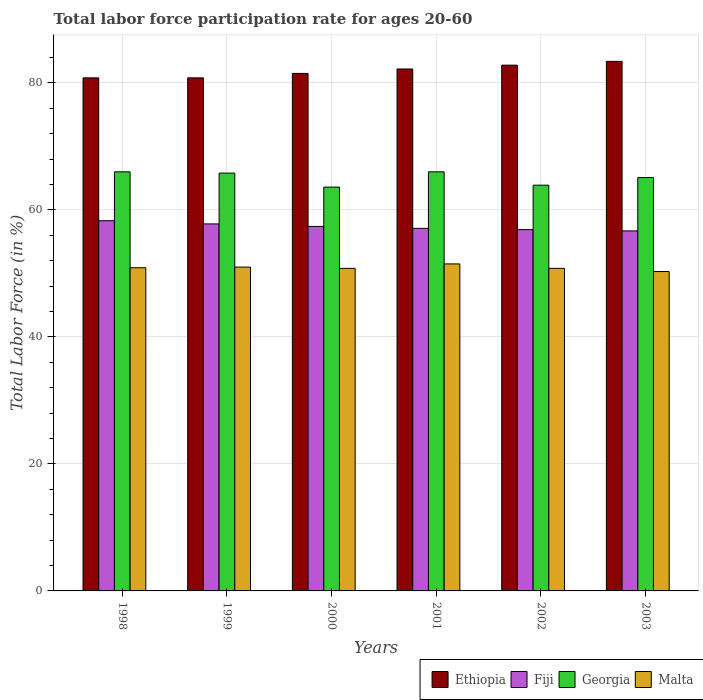How many different coloured bars are there?
Your answer should be compact. 4. Are the number of bars per tick equal to the number of legend labels?
Provide a short and direct response. Yes. Are the number of bars on each tick of the X-axis equal?
Ensure brevity in your answer.  Yes. How many bars are there on the 3rd tick from the right?
Your answer should be very brief. 4. What is the labor force participation rate in Malta in 1998?
Your response must be concise. 50.9. Across all years, what is the maximum labor force participation rate in Malta?
Your response must be concise. 51.5. Across all years, what is the minimum labor force participation rate in Fiji?
Make the answer very short. 56.7. In which year was the labor force participation rate in Fiji maximum?
Provide a short and direct response. 1998. What is the total labor force participation rate in Malta in the graph?
Make the answer very short. 305.3. What is the difference between the labor force participation rate in Malta in 1998 and that in 1999?
Provide a succinct answer. -0.1. What is the difference between the labor force participation rate in Fiji in 2003 and the labor force participation rate in Malta in 1998?
Provide a short and direct response. 5.8. What is the average labor force participation rate in Ethiopia per year?
Offer a terse response. 81.92. In the year 2000, what is the difference between the labor force participation rate in Ethiopia and labor force participation rate in Fiji?
Offer a very short reply. 24.1. In how many years, is the labor force participation rate in Ethiopia greater than 12 %?
Provide a succinct answer. 6. What is the ratio of the labor force participation rate in Ethiopia in 2002 to that in 2003?
Keep it short and to the point. 0.99. Is the difference between the labor force participation rate in Ethiopia in 2000 and 2003 greater than the difference between the labor force participation rate in Fiji in 2000 and 2003?
Keep it short and to the point. No. What is the difference between the highest and the second highest labor force participation rate in Ethiopia?
Your answer should be compact. 0.6. What is the difference between the highest and the lowest labor force participation rate in Ethiopia?
Provide a short and direct response. 2.6. Is it the case that in every year, the sum of the labor force participation rate in Ethiopia and labor force participation rate in Georgia is greater than the sum of labor force participation rate in Malta and labor force participation rate in Fiji?
Provide a short and direct response. Yes. What does the 2nd bar from the left in 1998 represents?
Your answer should be very brief. Fiji. What does the 3rd bar from the right in 2001 represents?
Offer a terse response. Fiji. Is it the case that in every year, the sum of the labor force participation rate in Georgia and labor force participation rate in Ethiopia is greater than the labor force participation rate in Malta?
Your answer should be compact. Yes. Are the values on the major ticks of Y-axis written in scientific E-notation?
Your answer should be very brief. No. Does the graph contain any zero values?
Offer a terse response. No. Does the graph contain grids?
Offer a terse response. Yes. Where does the legend appear in the graph?
Your response must be concise. Bottom right. How are the legend labels stacked?
Provide a succinct answer. Horizontal. What is the title of the graph?
Offer a very short reply. Total labor force participation rate for ages 20-60. What is the label or title of the X-axis?
Make the answer very short. Years. What is the Total Labor Force (in %) in Ethiopia in 1998?
Provide a short and direct response. 80.8. What is the Total Labor Force (in %) in Fiji in 1998?
Ensure brevity in your answer.  58.3. What is the Total Labor Force (in %) of Malta in 1998?
Ensure brevity in your answer.  50.9. What is the Total Labor Force (in %) in Ethiopia in 1999?
Your response must be concise. 80.8. What is the Total Labor Force (in %) of Fiji in 1999?
Provide a short and direct response. 57.8. What is the Total Labor Force (in %) in Georgia in 1999?
Give a very brief answer. 65.8. What is the Total Labor Force (in %) of Ethiopia in 2000?
Provide a short and direct response. 81.5. What is the Total Labor Force (in %) in Fiji in 2000?
Make the answer very short. 57.4. What is the Total Labor Force (in %) of Georgia in 2000?
Keep it short and to the point. 63.6. What is the Total Labor Force (in %) in Malta in 2000?
Keep it short and to the point. 50.8. What is the Total Labor Force (in %) of Ethiopia in 2001?
Offer a terse response. 82.2. What is the Total Labor Force (in %) of Fiji in 2001?
Offer a terse response. 57.1. What is the Total Labor Force (in %) of Malta in 2001?
Provide a succinct answer. 51.5. What is the Total Labor Force (in %) in Ethiopia in 2002?
Keep it short and to the point. 82.8. What is the Total Labor Force (in %) of Fiji in 2002?
Your answer should be compact. 56.9. What is the Total Labor Force (in %) of Georgia in 2002?
Provide a succinct answer. 63.9. What is the Total Labor Force (in %) of Malta in 2002?
Make the answer very short. 50.8. What is the Total Labor Force (in %) in Ethiopia in 2003?
Make the answer very short. 83.4. What is the Total Labor Force (in %) in Fiji in 2003?
Provide a short and direct response. 56.7. What is the Total Labor Force (in %) of Georgia in 2003?
Your answer should be very brief. 65.1. What is the Total Labor Force (in %) of Malta in 2003?
Make the answer very short. 50.3. Across all years, what is the maximum Total Labor Force (in %) of Ethiopia?
Make the answer very short. 83.4. Across all years, what is the maximum Total Labor Force (in %) of Fiji?
Ensure brevity in your answer.  58.3. Across all years, what is the maximum Total Labor Force (in %) of Georgia?
Keep it short and to the point. 66. Across all years, what is the maximum Total Labor Force (in %) in Malta?
Offer a terse response. 51.5. Across all years, what is the minimum Total Labor Force (in %) of Ethiopia?
Your response must be concise. 80.8. Across all years, what is the minimum Total Labor Force (in %) of Fiji?
Offer a terse response. 56.7. Across all years, what is the minimum Total Labor Force (in %) of Georgia?
Keep it short and to the point. 63.6. Across all years, what is the minimum Total Labor Force (in %) of Malta?
Your response must be concise. 50.3. What is the total Total Labor Force (in %) of Ethiopia in the graph?
Your response must be concise. 491.5. What is the total Total Labor Force (in %) of Fiji in the graph?
Make the answer very short. 344.2. What is the total Total Labor Force (in %) in Georgia in the graph?
Your answer should be compact. 390.4. What is the total Total Labor Force (in %) of Malta in the graph?
Provide a succinct answer. 305.3. What is the difference between the Total Labor Force (in %) in Georgia in 1998 and that in 1999?
Provide a succinct answer. 0.2. What is the difference between the Total Labor Force (in %) of Ethiopia in 1998 and that in 2000?
Your answer should be very brief. -0.7. What is the difference between the Total Labor Force (in %) in Fiji in 1998 and that in 2000?
Provide a succinct answer. 0.9. What is the difference between the Total Labor Force (in %) in Georgia in 1998 and that in 2000?
Provide a short and direct response. 2.4. What is the difference between the Total Labor Force (in %) of Malta in 1998 and that in 2000?
Your response must be concise. 0.1. What is the difference between the Total Labor Force (in %) in Ethiopia in 1998 and that in 2001?
Offer a very short reply. -1.4. What is the difference between the Total Labor Force (in %) of Georgia in 1998 and that in 2001?
Give a very brief answer. 0. What is the difference between the Total Labor Force (in %) of Ethiopia in 1998 and that in 2002?
Your answer should be compact. -2. What is the difference between the Total Labor Force (in %) of Fiji in 1998 and that in 2002?
Make the answer very short. 1.4. What is the difference between the Total Labor Force (in %) of Ethiopia in 1998 and that in 2003?
Provide a short and direct response. -2.6. What is the difference between the Total Labor Force (in %) of Georgia in 1998 and that in 2003?
Your answer should be compact. 0.9. What is the difference between the Total Labor Force (in %) in Malta in 1998 and that in 2003?
Make the answer very short. 0.6. What is the difference between the Total Labor Force (in %) in Fiji in 1999 and that in 2000?
Ensure brevity in your answer.  0.4. What is the difference between the Total Labor Force (in %) in Malta in 1999 and that in 2000?
Keep it short and to the point. 0.2. What is the difference between the Total Labor Force (in %) of Fiji in 1999 and that in 2001?
Make the answer very short. 0.7. What is the difference between the Total Labor Force (in %) of Georgia in 1999 and that in 2001?
Make the answer very short. -0.2. What is the difference between the Total Labor Force (in %) in Malta in 1999 and that in 2001?
Your response must be concise. -0.5. What is the difference between the Total Labor Force (in %) in Georgia in 1999 and that in 2002?
Provide a succinct answer. 1.9. What is the difference between the Total Labor Force (in %) in Fiji in 1999 and that in 2003?
Ensure brevity in your answer.  1.1. What is the difference between the Total Labor Force (in %) of Georgia in 2000 and that in 2001?
Your response must be concise. -2.4. What is the difference between the Total Labor Force (in %) in Ethiopia in 2000 and that in 2002?
Provide a short and direct response. -1.3. What is the difference between the Total Labor Force (in %) of Ethiopia in 2000 and that in 2003?
Ensure brevity in your answer.  -1.9. What is the difference between the Total Labor Force (in %) in Fiji in 2001 and that in 2002?
Provide a short and direct response. 0.2. What is the difference between the Total Labor Force (in %) in Georgia in 2001 and that in 2002?
Offer a very short reply. 2.1. What is the difference between the Total Labor Force (in %) in Fiji in 2001 and that in 2003?
Offer a very short reply. 0.4. What is the difference between the Total Labor Force (in %) in Georgia in 2001 and that in 2003?
Ensure brevity in your answer.  0.9. What is the difference between the Total Labor Force (in %) in Malta in 2001 and that in 2003?
Your response must be concise. 1.2. What is the difference between the Total Labor Force (in %) in Ethiopia in 2002 and that in 2003?
Provide a short and direct response. -0.6. What is the difference between the Total Labor Force (in %) in Georgia in 2002 and that in 2003?
Offer a very short reply. -1.2. What is the difference between the Total Labor Force (in %) in Malta in 2002 and that in 2003?
Provide a short and direct response. 0.5. What is the difference between the Total Labor Force (in %) of Ethiopia in 1998 and the Total Labor Force (in %) of Fiji in 1999?
Provide a short and direct response. 23. What is the difference between the Total Labor Force (in %) of Ethiopia in 1998 and the Total Labor Force (in %) of Georgia in 1999?
Offer a terse response. 15. What is the difference between the Total Labor Force (in %) of Ethiopia in 1998 and the Total Labor Force (in %) of Malta in 1999?
Give a very brief answer. 29.8. What is the difference between the Total Labor Force (in %) of Fiji in 1998 and the Total Labor Force (in %) of Malta in 1999?
Keep it short and to the point. 7.3. What is the difference between the Total Labor Force (in %) in Georgia in 1998 and the Total Labor Force (in %) in Malta in 1999?
Ensure brevity in your answer.  15. What is the difference between the Total Labor Force (in %) of Ethiopia in 1998 and the Total Labor Force (in %) of Fiji in 2000?
Provide a short and direct response. 23.4. What is the difference between the Total Labor Force (in %) in Fiji in 1998 and the Total Labor Force (in %) in Georgia in 2000?
Your answer should be very brief. -5.3. What is the difference between the Total Labor Force (in %) of Fiji in 1998 and the Total Labor Force (in %) of Malta in 2000?
Ensure brevity in your answer.  7.5. What is the difference between the Total Labor Force (in %) of Ethiopia in 1998 and the Total Labor Force (in %) of Fiji in 2001?
Offer a very short reply. 23.7. What is the difference between the Total Labor Force (in %) of Ethiopia in 1998 and the Total Labor Force (in %) of Malta in 2001?
Provide a short and direct response. 29.3. What is the difference between the Total Labor Force (in %) in Fiji in 1998 and the Total Labor Force (in %) in Georgia in 2001?
Ensure brevity in your answer.  -7.7. What is the difference between the Total Labor Force (in %) of Ethiopia in 1998 and the Total Labor Force (in %) of Fiji in 2002?
Provide a succinct answer. 23.9. What is the difference between the Total Labor Force (in %) in Ethiopia in 1998 and the Total Labor Force (in %) in Malta in 2002?
Give a very brief answer. 30. What is the difference between the Total Labor Force (in %) in Fiji in 1998 and the Total Labor Force (in %) in Malta in 2002?
Give a very brief answer. 7.5. What is the difference between the Total Labor Force (in %) of Georgia in 1998 and the Total Labor Force (in %) of Malta in 2002?
Keep it short and to the point. 15.2. What is the difference between the Total Labor Force (in %) of Ethiopia in 1998 and the Total Labor Force (in %) of Fiji in 2003?
Ensure brevity in your answer.  24.1. What is the difference between the Total Labor Force (in %) of Ethiopia in 1998 and the Total Labor Force (in %) of Malta in 2003?
Provide a succinct answer. 30.5. What is the difference between the Total Labor Force (in %) in Fiji in 1998 and the Total Labor Force (in %) in Georgia in 2003?
Your answer should be compact. -6.8. What is the difference between the Total Labor Force (in %) of Fiji in 1998 and the Total Labor Force (in %) of Malta in 2003?
Ensure brevity in your answer.  8. What is the difference between the Total Labor Force (in %) in Ethiopia in 1999 and the Total Labor Force (in %) in Fiji in 2000?
Keep it short and to the point. 23.4. What is the difference between the Total Labor Force (in %) in Ethiopia in 1999 and the Total Labor Force (in %) in Malta in 2000?
Give a very brief answer. 30. What is the difference between the Total Labor Force (in %) in Ethiopia in 1999 and the Total Labor Force (in %) in Fiji in 2001?
Offer a terse response. 23.7. What is the difference between the Total Labor Force (in %) of Ethiopia in 1999 and the Total Labor Force (in %) of Malta in 2001?
Provide a short and direct response. 29.3. What is the difference between the Total Labor Force (in %) in Georgia in 1999 and the Total Labor Force (in %) in Malta in 2001?
Offer a very short reply. 14.3. What is the difference between the Total Labor Force (in %) in Ethiopia in 1999 and the Total Labor Force (in %) in Fiji in 2002?
Give a very brief answer. 23.9. What is the difference between the Total Labor Force (in %) of Ethiopia in 1999 and the Total Labor Force (in %) of Malta in 2002?
Your response must be concise. 30. What is the difference between the Total Labor Force (in %) in Fiji in 1999 and the Total Labor Force (in %) in Georgia in 2002?
Offer a very short reply. -6.1. What is the difference between the Total Labor Force (in %) in Fiji in 1999 and the Total Labor Force (in %) in Malta in 2002?
Your answer should be compact. 7. What is the difference between the Total Labor Force (in %) of Ethiopia in 1999 and the Total Labor Force (in %) of Fiji in 2003?
Your answer should be compact. 24.1. What is the difference between the Total Labor Force (in %) in Ethiopia in 1999 and the Total Labor Force (in %) in Georgia in 2003?
Give a very brief answer. 15.7. What is the difference between the Total Labor Force (in %) in Ethiopia in 1999 and the Total Labor Force (in %) in Malta in 2003?
Offer a terse response. 30.5. What is the difference between the Total Labor Force (in %) in Georgia in 1999 and the Total Labor Force (in %) in Malta in 2003?
Give a very brief answer. 15.5. What is the difference between the Total Labor Force (in %) of Ethiopia in 2000 and the Total Labor Force (in %) of Fiji in 2001?
Keep it short and to the point. 24.4. What is the difference between the Total Labor Force (in %) in Ethiopia in 2000 and the Total Labor Force (in %) in Georgia in 2001?
Your answer should be very brief. 15.5. What is the difference between the Total Labor Force (in %) of Ethiopia in 2000 and the Total Labor Force (in %) of Malta in 2001?
Give a very brief answer. 30. What is the difference between the Total Labor Force (in %) of Fiji in 2000 and the Total Labor Force (in %) of Georgia in 2001?
Provide a short and direct response. -8.6. What is the difference between the Total Labor Force (in %) of Fiji in 2000 and the Total Labor Force (in %) of Malta in 2001?
Your answer should be very brief. 5.9. What is the difference between the Total Labor Force (in %) of Ethiopia in 2000 and the Total Labor Force (in %) of Fiji in 2002?
Your response must be concise. 24.6. What is the difference between the Total Labor Force (in %) in Ethiopia in 2000 and the Total Labor Force (in %) in Georgia in 2002?
Your answer should be very brief. 17.6. What is the difference between the Total Labor Force (in %) of Ethiopia in 2000 and the Total Labor Force (in %) of Malta in 2002?
Your answer should be very brief. 30.7. What is the difference between the Total Labor Force (in %) in Ethiopia in 2000 and the Total Labor Force (in %) in Fiji in 2003?
Your answer should be very brief. 24.8. What is the difference between the Total Labor Force (in %) in Ethiopia in 2000 and the Total Labor Force (in %) in Georgia in 2003?
Keep it short and to the point. 16.4. What is the difference between the Total Labor Force (in %) of Ethiopia in 2000 and the Total Labor Force (in %) of Malta in 2003?
Ensure brevity in your answer.  31.2. What is the difference between the Total Labor Force (in %) in Georgia in 2000 and the Total Labor Force (in %) in Malta in 2003?
Make the answer very short. 13.3. What is the difference between the Total Labor Force (in %) in Ethiopia in 2001 and the Total Labor Force (in %) in Fiji in 2002?
Give a very brief answer. 25.3. What is the difference between the Total Labor Force (in %) of Ethiopia in 2001 and the Total Labor Force (in %) of Georgia in 2002?
Provide a short and direct response. 18.3. What is the difference between the Total Labor Force (in %) in Ethiopia in 2001 and the Total Labor Force (in %) in Malta in 2002?
Your response must be concise. 31.4. What is the difference between the Total Labor Force (in %) in Fiji in 2001 and the Total Labor Force (in %) in Georgia in 2002?
Ensure brevity in your answer.  -6.8. What is the difference between the Total Labor Force (in %) in Georgia in 2001 and the Total Labor Force (in %) in Malta in 2002?
Provide a short and direct response. 15.2. What is the difference between the Total Labor Force (in %) of Ethiopia in 2001 and the Total Labor Force (in %) of Fiji in 2003?
Give a very brief answer. 25.5. What is the difference between the Total Labor Force (in %) in Ethiopia in 2001 and the Total Labor Force (in %) in Georgia in 2003?
Offer a terse response. 17.1. What is the difference between the Total Labor Force (in %) of Ethiopia in 2001 and the Total Labor Force (in %) of Malta in 2003?
Offer a very short reply. 31.9. What is the difference between the Total Labor Force (in %) of Fiji in 2001 and the Total Labor Force (in %) of Malta in 2003?
Make the answer very short. 6.8. What is the difference between the Total Labor Force (in %) in Georgia in 2001 and the Total Labor Force (in %) in Malta in 2003?
Offer a terse response. 15.7. What is the difference between the Total Labor Force (in %) in Ethiopia in 2002 and the Total Labor Force (in %) in Fiji in 2003?
Make the answer very short. 26.1. What is the difference between the Total Labor Force (in %) in Ethiopia in 2002 and the Total Labor Force (in %) in Malta in 2003?
Provide a succinct answer. 32.5. What is the average Total Labor Force (in %) of Ethiopia per year?
Provide a succinct answer. 81.92. What is the average Total Labor Force (in %) in Fiji per year?
Give a very brief answer. 57.37. What is the average Total Labor Force (in %) of Georgia per year?
Your response must be concise. 65.07. What is the average Total Labor Force (in %) of Malta per year?
Provide a short and direct response. 50.88. In the year 1998, what is the difference between the Total Labor Force (in %) of Ethiopia and Total Labor Force (in %) of Malta?
Your response must be concise. 29.9. In the year 1998, what is the difference between the Total Labor Force (in %) of Georgia and Total Labor Force (in %) of Malta?
Ensure brevity in your answer.  15.1. In the year 1999, what is the difference between the Total Labor Force (in %) of Ethiopia and Total Labor Force (in %) of Fiji?
Ensure brevity in your answer.  23. In the year 1999, what is the difference between the Total Labor Force (in %) in Ethiopia and Total Labor Force (in %) in Malta?
Make the answer very short. 29.8. In the year 1999, what is the difference between the Total Labor Force (in %) of Fiji and Total Labor Force (in %) of Georgia?
Keep it short and to the point. -8. In the year 2000, what is the difference between the Total Labor Force (in %) of Ethiopia and Total Labor Force (in %) of Fiji?
Ensure brevity in your answer.  24.1. In the year 2000, what is the difference between the Total Labor Force (in %) in Ethiopia and Total Labor Force (in %) in Malta?
Offer a very short reply. 30.7. In the year 2000, what is the difference between the Total Labor Force (in %) in Fiji and Total Labor Force (in %) in Malta?
Your answer should be compact. 6.6. In the year 2001, what is the difference between the Total Labor Force (in %) in Ethiopia and Total Labor Force (in %) in Fiji?
Offer a very short reply. 25.1. In the year 2001, what is the difference between the Total Labor Force (in %) in Ethiopia and Total Labor Force (in %) in Malta?
Give a very brief answer. 30.7. In the year 2002, what is the difference between the Total Labor Force (in %) of Ethiopia and Total Labor Force (in %) of Fiji?
Your response must be concise. 25.9. In the year 2002, what is the difference between the Total Labor Force (in %) of Ethiopia and Total Labor Force (in %) of Malta?
Offer a very short reply. 32. In the year 2002, what is the difference between the Total Labor Force (in %) of Fiji and Total Labor Force (in %) of Georgia?
Your response must be concise. -7. In the year 2003, what is the difference between the Total Labor Force (in %) in Ethiopia and Total Labor Force (in %) in Fiji?
Your answer should be very brief. 26.7. In the year 2003, what is the difference between the Total Labor Force (in %) of Ethiopia and Total Labor Force (in %) of Malta?
Provide a short and direct response. 33.1. In the year 2003, what is the difference between the Total Labor Force (in %) in Fiji and Total Labor Force (in %) in Malta?
Your answer should be compact. 6.4. What is the ratio of the Total Labor Force (in %) of Ethiopia in 1998 to that in 1999?
Offer a terse response. 1. What is the ratio of the Total Labor Force (in %) in Fiji in 1998 to that in 1999?
Provide a succinct answer. 1.01. What is the ratio of the Total Labor Force (in %) of Malta in 1998 to that in 1999?
Ensure brevity in your answer.  1. What is the ratio of the Total Labor Force (in %) of Fiji in 1998 to that in 2000?
Your answer should be very brief. 1.02. What is the ratio of the Total Labor Force (in %) of Georgia in 1998 to that in 2000?
Give a very brief answer. 1.04. What is the ratio of the Total Labor Force (in %) of Ethiopia in 1998 to that in 2001?
Offer a terse response. 0.98. What is the ratio of the Total Labor Force (in %) of Fiji in 1998 to that in 2001?
Offer a very short reply. 1.02. What is the ratio of the Total Labor Force (in %) in Malta in 1998 to that in 2001?
Provide a succinct answer. 0.99. What is the ratio of the Total Labor Force (in %) of Ethiopia in 1998 to that in 2002?
Your answer should be very brief. 0.98. What is the ratio of the Total Labor Force (in %) in Fiji in 1998 to that in 2002?
Provide a succinct answer. 1.02. What is the ratio of the Total Labor Force (in %) in Georgia in 1998 to that in 2002?
Your answer should be very brief. 1.03. What is the ratio of the Total Labor Force (in %) of Ethiopia in 1998 to that in 2003?
Ensure brevity in your answer.  0.97. What is the ratio of the Total Labor Force (in %) in Fiji in 1998 to that in 2003?
Provide a succinct answer. 1.03. What is the ratio of the Total Labor Force (in %) in Georgia in 1998 to that in 2003?
Make the answer very short. 1.01. What is the ratio of the Total Labor Force (in %) in Malta in 1998 to that in 2003?
Give a very brief answer. 1.01. What is the ratio of the Total Labor Force (in %) of Fiji in 1999 to that in 2000?
Keep it short and to the point. 1.01. What is the ratio of the Total Labor Force (in %) in Georgia in 1999 to that in 2000?
Give a very brief answer. 1.03. What is the ratio of the Total Labor Force (in %) in Ethiopia in 1999 to that in 2001?
Your answer should be very brief. 0.98. What is the ratio of the Total Labor Force (in %) of Fiji in 1999 to that in 2001?
Your answer should be very brief. 1.01. What is the ratio of the Total Labor Force (in %) in Georgia in 1999 to that in 2001?
Give a very brief answer. 1. What is the ratio of the Total Labor Force (in %) of Malta in 1999 to that in 2001?
Your answer should be compact. 0.99. What is the ratio of the Total Labor Force (in %) in Ethiopia in 1999 to that in 2002?
Offer a terse response. 0.98. What is the ratio of the Total Labor Force (in %) in Fiji in 1999 to that in 2002?
Your answer should be compact. 1.02. What is the ratio of the Total Labor Force (in %) in Georgia in 1999 to that in 2002?
Your answer should be compact. 1.03. What is the ratio of the Total Labor Force (in %) in Ethiopia in 1999 to that in 2003?
Your answer should be compact. 0.97. What is the ratio of the Total Labor Force (in %) of Fiji in 1999 to that in 2003?
Provide a succinct answer. 1.02. What is the ratio of the Total Labor Force (in %) in Georgia in 1999 to that in 2003?
Give a very brief answer. 1.01. What is the ratio of the Total Labor Force (in %) of Malta in 1999 to that in 2003?
Provide a short and direct response. 1.01. What is the ratio of the Total Labor Force (in %) in Fiji in 2000 to that in 2001?
Your response must be concise. 1.01. What is the ratio of the Total Labor Force (in %) in Georgia in 2000 to that in 2001?
Offer a terse response. 0.96. What is the ratio of the Total Labor Force (in %) in Malta in 2000 to that in 2001?
Offer a very short reply. 0.99. What is the ratio of the Total Labor Force (in %) in Ethiopia in 2000 to that in 2002?
Give a very brief answer. 0.98. What is the ratio of the Total Labor Force (in %) of Fiji in 2000 to that in 2002?
Provide a short and direct response. 1.01. What is the ratio of the Total Labor Force (in %) in Ethiopia in 2000 to that in 2003?
Offer a terse response. 0.98. What is the ratio of the Total Labor Force (in %) of Fiji in 2000 to that in 2003?
Your answer should be very brief. 1.01. What is the ratio of the Total Labor Force (in %) of Malta in 2000 to that in 2003?
Your answer should be very brief. 1.01. What is the ratio of the Total Labor Force (in %) of Georgia in 2001 to that in 2002?
Ensure brevity in your answer.  1.03. What is the ratio of the Total Labor Force (in %) of Malta in 2001 to that in 2002?
Keep it short and to the point. 1.01. What is the ratio of the Total Labor Force (in %) in Ethiopia in 2001 to that in 2003?
Give a very brief answer. 0.99. What is the ratio of the Total Labor Force (in %) in Fiji in 2001 to that in 2003?
Keep it short and to the point. 1.01. What is the ratio of the Total Labor Force (in %) in Georgia in 2001 to that in 2003?
Make the answer very short. 1.01. What is the ratio of the Total Labor Force (in %) of Malta in 2001 to that in 2003?
Your response must be concise. 1.02. What is the ratio of the Total Labor Force (in %) in Georgia in 2002 to that in 2003?
Keep it short and to the point. 0.98. What is the ratio of the Total Labor Force (in %) of Malta in 2002 to that in 2003?
Keep it short and to the point. 1.01. What is the difference between the highest and the second highest Total Labor Force (in %) of Ethiopia?
Provide a short and direct response. 0.6. What is the difference between the highest and the second highest Total Labor Force (in %) of Fiji?
Your answer should be very brief. 0.5. What is the difference between the highest and the second highest Total Labor Force (in %) of Georgia?
Provide a succinct answer. 0. What is the difference between the highest and the second highest Total Labor Force (in %) in Malta?
Your answer should be compact. 0.5. What is the difference between the highest and the lowest Total Labor Force (in %) in Ethiopia?
Provide a succinct answer. 2.6. What is the difference between the highest and the lowest Total Labor Force (in %) of Georgia?
Your answer should be compact. 2.4. 